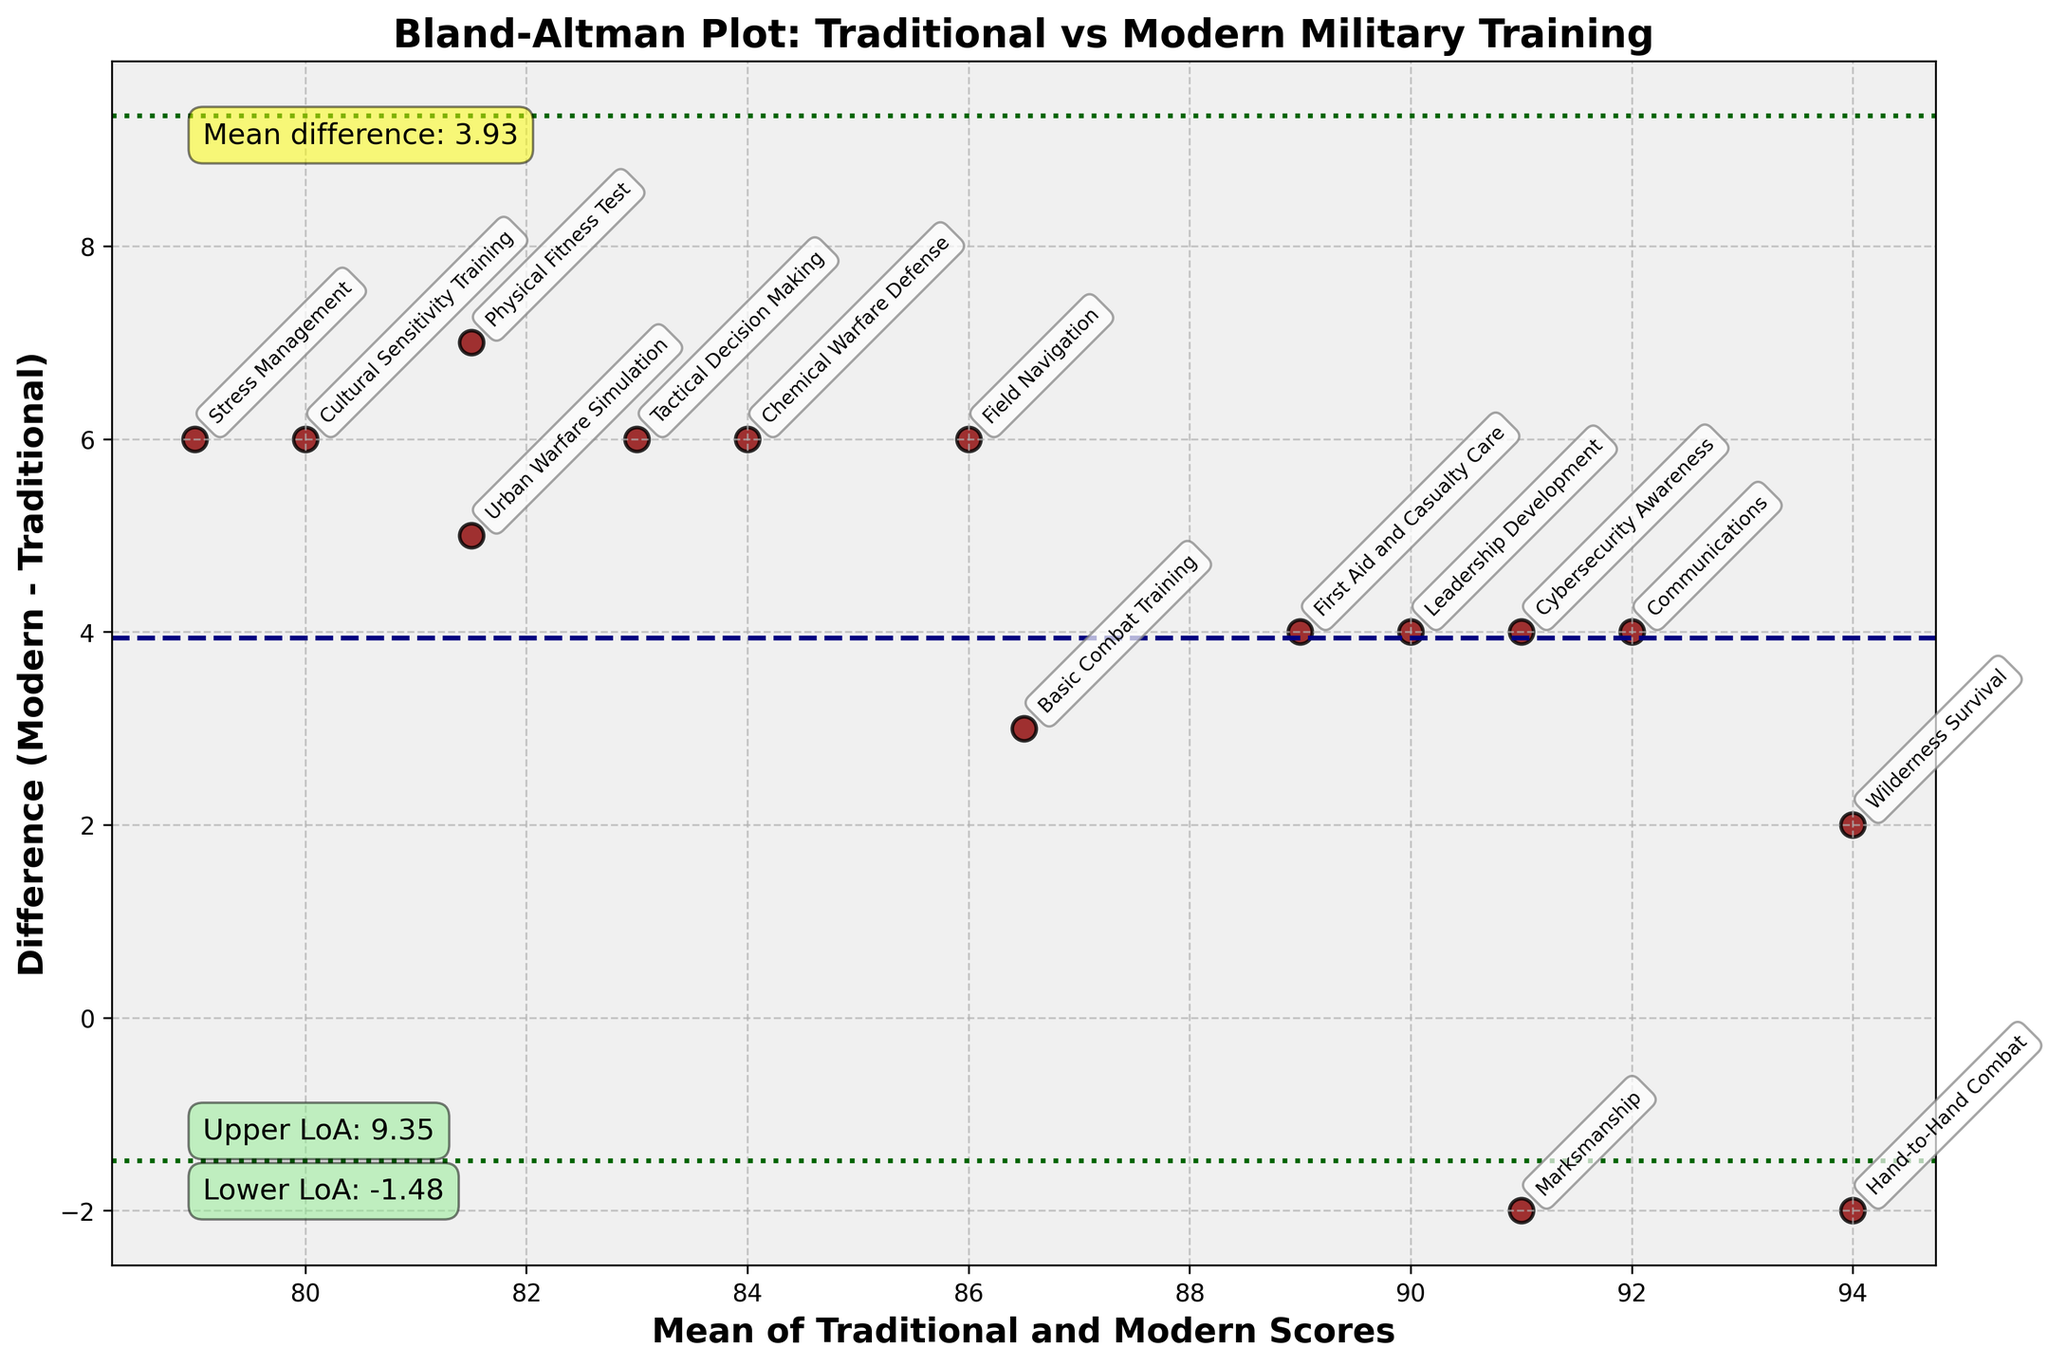What is the mean difference between the traditional and modern scores? The mean difference is marked with a dashed line and an annotation on the figure, showing the average difference between traditional and modern scores.
Answer: 3.87 What are the limits of agreement for the differences between traditional and modern scores? The limits of agreement are represented by two dotted lines and annotations on the figure, showing the range within which most differences are expected to fall.
Answer: (1.65, 6.09) What is the title of the plot? The title is displayed at the top of the plot and indicates the comparison being made.
Answer: Bland-Altman Plot: Traditional vs Modern Military Training How many data points are plotted in the Bland-Altman plot? Each data point on the plot corresponds to a training exercise, and they are spread across the plot. By counting them, we get the total number of data points.
Answer: 15 Which training exercise showed the greatest positive difference between modern and traditional scores? The greatest positive difference is represented by the data point with the highest value on the vertical axis (difference), and we can identify the labeled training exercise next to it.
Answer: Leadership Development Which training exercise had the smallest mean score? The mean score is represented on the horizontal axis. The smallest mean score is identified by looking for the data point lowest on this axis.
Answer: Stress Management Which data points fall outside the limits of agreement? The limits of agreement are marked with dotted lines above and below the mean difference. Data points that fall outside these lines represent scores with differences beyond the expected range.
Answer: None What is the mean score for "Urban Warfare Simulation"? The mean score is the average of the traditional and modern scores for "Urban Warfare Simulation", marked by the position on the horizontal axis. Calculation: (79+84)/2 = 81.5.
Answer: 81.5 